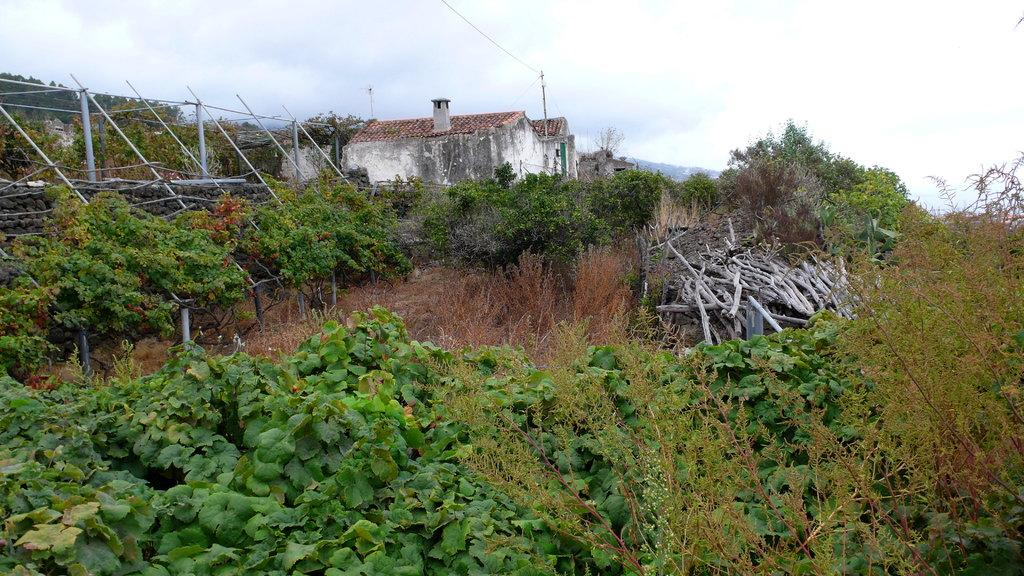What type of natural elements can be seen in the image? There are plants, woods, and mountains visible in the image. What is the condition of the plants on the ground? The plants on the ground are dry. What structures are present in the image? There are poles and houses in the image. What is visible in the sky? There are clouds in the sky. What type of jewel is being used to paint the mountains in the image? There is no jewel present in the image, and the mountains are not being painted. What type of brush is being used to create the clouds in the image? There is no brush present in the image, and the clouds are natural formations in the sky. 